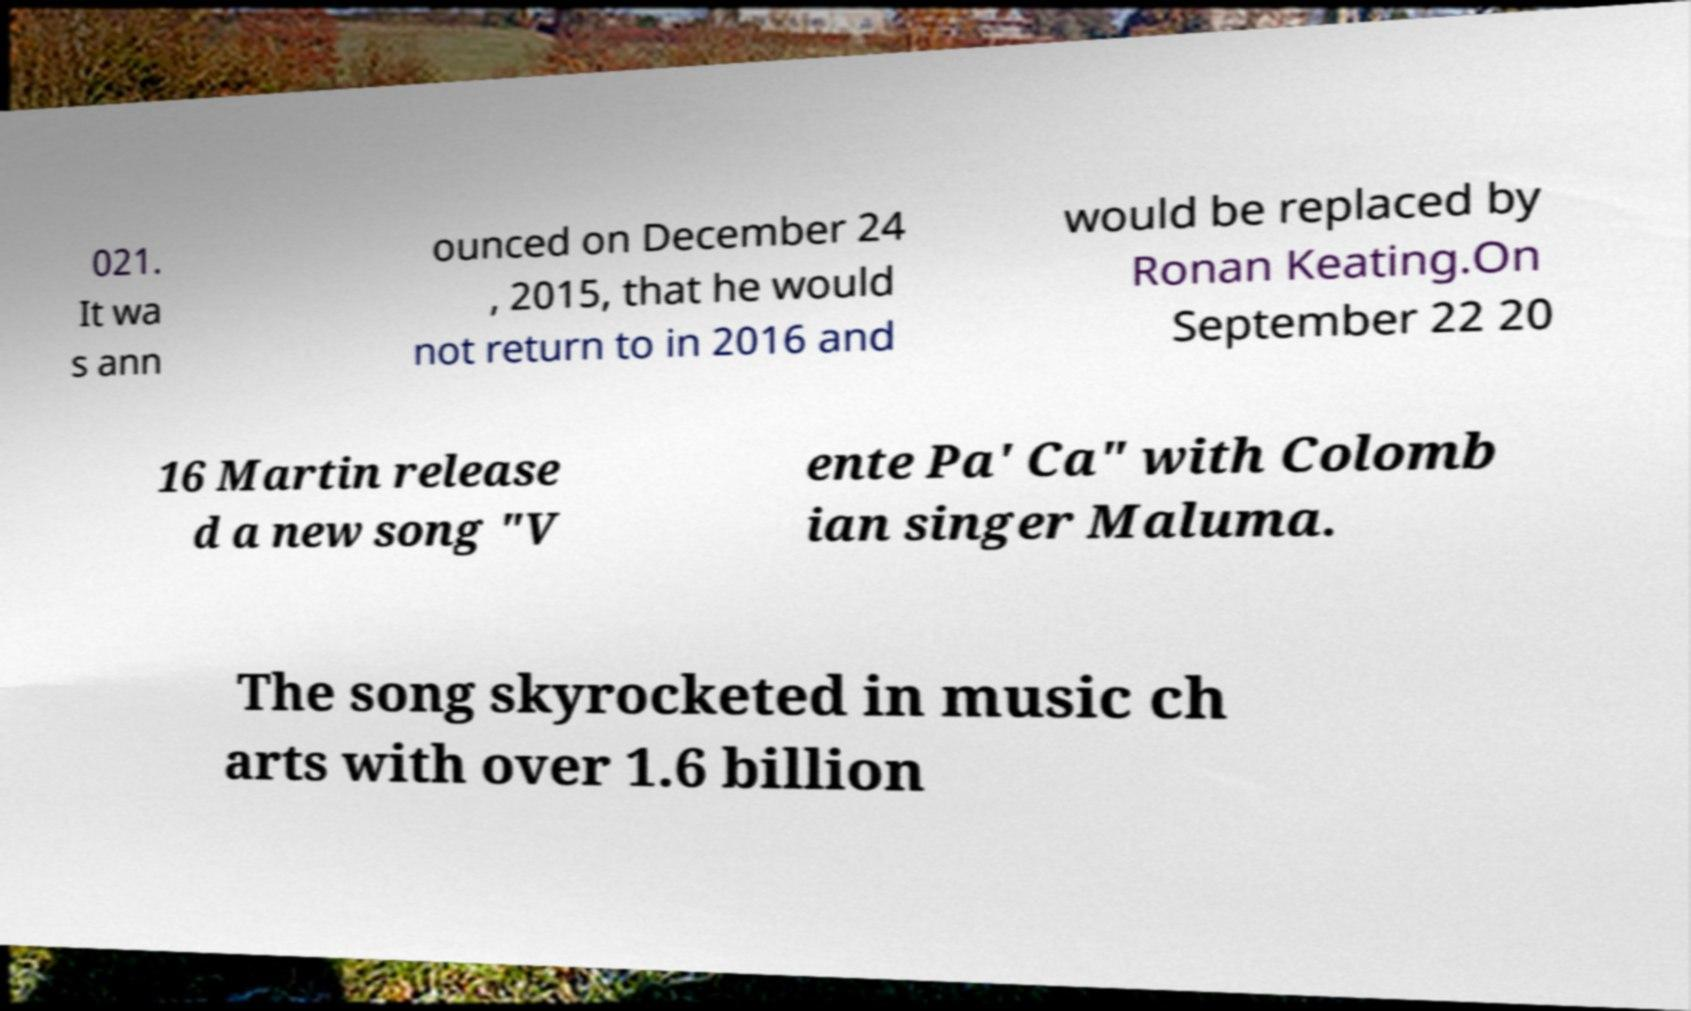Can you read and provide the text displayed in the image?This photo seems to have some interesting text. Can you extract and type it out for me? 021. It wa s ann ounced on December 24 , 2015, that he would not return to in 2016 and would be replaced by Ronan Keating.On September 22 20 16 Martin release d a new song "V ente Pa' Ca" with Colomb ian singer Maluma. The song skyrocketed in music ch arts with over 1.6 billion 